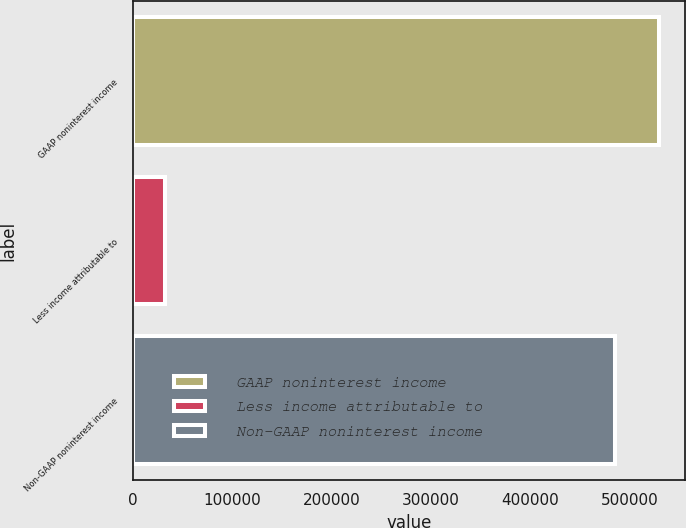Convert chart to OTSL. <chart><loc_0><loc_0><loc_500><loc_500><bar_chart><fcel>GAAP noninterest income<fcel>Less income attributable to<fcel>Non-GAAP noninterest income<nl><fcel>529270<fcel>31736<fcel>485164<nl></chart> 